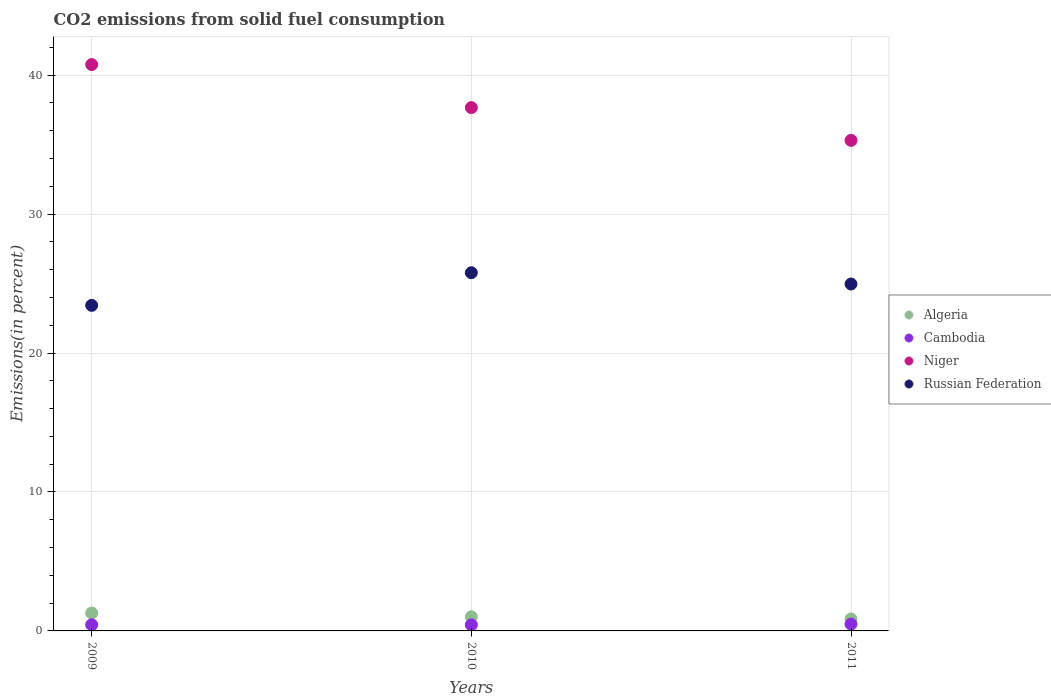Is the number of dotlines equal to the number of legend labels?
Offer a very short reply. Yes. What is the total CO2 emitted in Algeria in 2009?
Make the answer very short. 1.29. Across all years, what is the maximum total CO2 emitted in Algeria?
Make the answer very short. 1.29. Across all years, what is the minimum total CO2 emitted in Cambodia?
Your answer should be very brief. 0.44. In which year was the total CO2 emitted in Cambodia maximum?
Make the answer very short. 2011. What is the total total CO2 emitted in Niger in the graph?
Provide a succinct answer. 113.74. What is the difference between the total CO2 emitted in Cambodia in 2009 and that in 2010?
Your answer should be compact. 0.01. What is the difference between the total CO2 emitted in Algeria in 2010 and the total CO2 emitted in Cambodia in 2009?
Ensure brevity in your answer.  0.58. What is the average total CO2 emitted in Russian Federation per year?
Your answer should be compact. 24.73. In the year 2009, what is the difference between the total CO2 emitted in Niger and total CO2 emitted in Cambodia?
Offer a terse response. 40.32. What is the ratio of the total CO2 emitted in Algeria in 2009 to that in 2010?
Make the answer very short. 1.26. What is the difference between the highest and the second highest total CO2 emitted in Cambodia?
Ensure brevity in your answer.  0.05. What is the difference between the highest and the lowest total CO2 emitted in Cambodia?
Ensure brevity in your answer.  0.05. Is the sum of the total CO2 emitted in Cambodia in 2010 and 2011 greater than the maximum total CO2 emitted in Niger across all years?
Your answer should be very brief. No. Is it the case that in every year, the sum of the total CO2 emitted in Russian Federation and total CO2 emitted in Algeria  is greater than the sum of total CO2 emitted in Niger and total CO2 emitted in Cambodia?
Your answer should be very brief. Yes. Is it the case that in every year, the sum of the total CO2 emitted in Cambodia and total CO2 emitted in Russian Federation  is greater than the total CO2 emitted in Algeria?
Give a very brief answer. Yes. Does the total CO2 emitted in Algeria monotonically increase over the years?
Provide a succinct answer. No. How many dotlines are there?
Ensure brevity in your answer.  4. How many years are there in the graph?
Provide a succinct answer. 3. Are the values on the major ticks of Y-axis written in scientific E-notation?
Provide a short and direct response. No. Does the graph contain any zero values?
Your answer should be compact. No. How are the legend labels stacked?
Your answer should be compact. Vertical. What is the title of the graph?
Your response must be concise. CO2 emissions from solid fuel consumption. Does "Czech Republic" appear as one of the legend labels in the graph?
Your answer should be very brief. No. What is the label or title of the X-axis?
Your response must be concise. Years. What is the label or title of the Y-axis?
Your answer should be compact. Emissions(in percent). What is the Emissions(in percent) of Algeria in 2009?
Ensure brevity in your answer.  1.29. What is the Emissions(in percent) in Cambodia in 2009?
Your answer should be compact. 0.44. What is the Emissions(in percent) of Niger in 2009?
Make the answer very short. 40.76. What is the Emissions(in percent) of Russian Federation in 2009?
Offer a terse response. 23.43. What is the Emissions(in percent) of Algeria in 2010?
Give a very brief answer. 1.02. What is the Emissions(in percent) of Cambodia in 2010?
Give a very brief answer. 0.44. What is the Emissions(in percent) in Niger in 2010?
Offer a very short reply. 37.67. What is the Emissions(in percent) in Russian Federation in 2010?
Make the answer very short. 25.78. What is the Emissions(in percent) in Algeria in 2011?
Provide a succinct answer. 0.86. What is the Emissions(in percent) of Cambodia in 2011?
Ensure brevity in your answer.  0.49. What is the Emissions(in percent) in Niger in 2011?
Offer a terse response. 35.31. What is the Emissions(in percent) in Russian Federation in 2011?
Offer a terse response. 24.97. Across all years, what is the maximum Emissions(in percent) of Algeria?
Your answer should be compact. 1.29. Across all years, what is the maximum Emissions(in percent) of Cambodia?
Offer a terse response. 0.49. Across all years, what is the maximum Emissions(in percent) in Niger?
Offer a very short reply. 40.76. Across all years, what is the maximum Emissions(in percent) of Russian Federation?
Make the answer very short. 25.78. Across all years, what is the minimum Emissions(in percent) in Algeria?
Offer a terse response. 0.86. Across all years, what is the minimum Emissions(in percent) of Cambodia?
Provide a short and direct response. 0.44. Across all years, what is the minimum Emissions(in percent) of Niger?
Offer a terse response. 35.31. Across all years, what is the minimum Emissions(in percent) of Russian Federation?
Ensure brevity in your answer.  23.43. What is the total Emissions(in percent) of Algeria in the graph?
Provide a succinct answer. 3.17. What is the total Emissions(in percent) of Cambodia in the graph?
Your answer should be compact. 1.37. What is the total Emissions(in percent) of Niger in the graph?
Your answer should be compact. 113.74. What is the total Emissions(in percent) in Russian Federation in the graph?
Provide a succinct answer. 74.19. What is the difference between the Emissions(in percent) in Algeria in 2009 and that in 2010?
Ensure brevity in your answer.  0.27. What is the difference between the Emissions(in percent) of Cambodia in 2009 and that in 2010?
Ensure brevity in your answer.  0.01. What is the difference between the Emissions(in percent) in Niger in 2009 and that in 2010?
Offer a terse response. 3.1. What is the difference between the Emissions(in percent) of Russian Federation in 2009 and that in 2010?
Your response must be concise. -2.35. What is the difference between the Emissions(in percent) of Algeria in 2009 and that in 2011?
Ensure brevity in your answer.  0.43. What is the difference between the Emissions(in percent) in Cambodia in 2009 and that in 2011?
Offer a very short reply. -0.05. What is the difference between the Emissions(in percent) of Niger in 2009 and that in 2011?
Provide a succinct answer. 5.46. What is the difference between the Emissions(in percent) in Russian Federation in 2009 and that in 2011?
Your answer should be very brief. -1.54. What is the difference between the Emissions(in percent) of Algeria in 2010 and that in 2011?
Make the answer very short. 0.16. What is the difference between the Emissions(in percent) in Cambodia in 2010 and that in 2011?
Give a very brief answer. -0.05. What is the difference between the Emissions(in percent) of Niger in 2010 and that in 2011?
Ensure brevity in your answer.  2.36. What is the difference between the Emissions(in percent) in Russian Federation in 2010 and that in 2011?
Make the answer very short. 0.81. What is the difference between the Emissions(in percent) of Algeria in 2009 and the Emissions(in percent) of Cambodia in 2010?
Make the answer very short. 0.85. What is the difference between the Emissions(in percent) of Algeria in 2009 and the Emissions(in percent) of Niger in 2010?
Offer a terse response. -36.38. What is the difference between the Emissions(in percent) in Algeria in 2009 and the Emissions(in percent) in Russian Federation in 2010?
Ensure brevity in your answer.  -24.49. What is the difference between the Emissions(in percent) of Cambodia in 2009 and the Emissions(in percent) of Niger in 2010?
Offer a terse response. -37.23. What is the difference between the Emissions(in percent) of Cambodia in 2009 and the Emissions(in percent) of Russian Federation in 2010?
Ensure brevity in your answer.  -25.34. What is the difference between the Emissions(in percent) of Niger in 2009 and the Emissions(in percent) of Russian Federation in 2010?
Your answer should be compact. 14.98. What is the difference between the Emissions(in percent) of Algeria in 2009 and the Emissions(in percent) of Cambodia in 2011?
Offer a terse response. 0.8. What is the difference between the Emissions(in percent) of Algeria in 2009 and the Emissions(in percent) of Niger in 2011?
Your answer should be very brief. -34.02. What is the difference between the Emissions(in percent) in Algeria in 2009 and the Emissions(in percent) in Russian Federation in 2011?
Make the answer very short. -23.68. What is the difference between the Emissions(in percent) in Cambodia in 2009 and the Emissions(in percent) in Niger in 2011?
Your answer should be compact. -34.87. What is the difference between the Emissions(in percent) of Cambodia in 2009 and the Emissions(in percent) of Russian Federation in 2011?
Your answer should be very brief. -24.53. What is the difference between the Emissions(in percent) of Niger in 2009 and the Emissions(in percent) of Russian Federation in 2011?
Your answer should be very brief. 15.79. What is the difference between the Emissions(in percent) of Algeria in 2010 and the Emissions(in percent) of Cambodia in 2011?
Your answer should be compact. 0.53. What is the difference between the Emissions(in percent) of Algeria in 2010 and the Emissions(in percent) of Niger in 2011?
Your answer should be very brief. -34.29. What is the difference between the Emissions(in percent) of Algeria in 2010 and the Emissions(in percent) of Russian Federation in 2011?
Your answer should be compact. -23.95. What is the difference between the Emissions(in percent) in Cambodia in 2010 and the Emissions(in percent) in Niger in 2011?
Provide a succinct answer. -34.87. What is the difference between the Emissions(in percent) in Cambodia in 2010 and the Emissions(in percent) in Russian Federation in 2011?
Your answer should be compact. -24.53. What is the difference between the Emissions(in percent) in Niger in 2010 and the Emissions(in percent) in Russian Federation in 2011?
Offer a very short reply. 12.7. What is the average Emissions(in percent) in Algeria per year?
Your answer should be compact. 1.06. What is the average Emissions(in percent) of Cambodia per year?
Your answer should be very brief. 0.46. What is the average Emissions(in percent) in Niger per year?
Your response must be concise. 37.91. What is the average Emissions(in percent) in Russian Federation per year?
Provide a short and direct response. 24.73. In the year 2009, what is the difference between the Emissions(in percent) of Algeria and Emissions(in percent) of Cambodia?
Your answer should be compact. 0.85. In the year 2009, what is the difference between the Emissions(in percent) in Algeria and Emissions(in percent) in Niger?
Offer a very short reply. -39.47. In the year 2009, what is the difference between the Emissions(in percent) of Algeria and Emissions(in percent) of Russian Federation?
Give a very brief answer. -22.14. In the year 2009, what is the difference between the Emissions(in percent) of Cambodia and Emissions(in percent) of Niger?
Provide a short and direct response. -40.32. In the year 2009, what is the difference between the Emissions(in percent) of Cambodia and Emissions(in percent) of Russian Federation?
Offer a terse response. -22.99. In the year 2009, what is the difference between the Emissions(in percent) in Niger and Emissions(in percent) in Russian Federation?
Your answer should be very brief. 17.33. In the year 2010, what is the difference between the Emissions(in percent) of Algeria and Emissions(in percent) of Cambodia?
Provide a succinct answer. 0.58. In the year 2010, what is the difference between the Emissions(in percent) in Algeria and Emissions(in percent) in Niger?
Your response must be concise. -36.65. In the year 2010, what is the difference between the Emissions(in percent) of Algeria and Emissions(in percent) of Russian Federation?
Your answer should be compact. -24.76. In the year 2010, what is the difference between the Emissions(in percent) in Cambodia and Emissions(in percent) in Niger?
Your response must be concise. -37.23. In the year 2010, what is the difference between the Emissions(in percent) in Cambodia and Emissions(in percent) in Russian Federation?
Your answer should be very brief. -25.35. In the year 2010, what is the difference between the Emissions(in percent) in Niger and Emissions(in percent) in Russian Federation?
Your response must be concise. 11.89. In the year 2011, what is the difference between the Emissions(in percent) of Algeria and Emissions(in percent) of Cambodia?
Offer a very short reply. 0.37. In the year 2011, what is the difference between the Emissions(in percent) in Algeria and Emissions(in percent) in Niger?
Give a very brief answer. -34.45. In the year 2011, what is the difference between the Emissions(in percent) of Algeria and Emissions(in percent) of Russian Federation?
Make the answer very short. -24.11. In the year 2011, what is the difference between the Emissions(in percent) in Cambodia and Emissions(in percent) in Niger?
Provide a short and direct response. -34.82. In the year 2011, what is the difference between the Emissions(in percent) in Cambodia and Emissions(in percent) in Russian Federation?
Your response must be concise. -24.48. In the year 2011, what is the difference between the Emissions(in percent) in Niger and Emissions(in percent) in Russian Federation?
Keep it short and to the point. 10.34. What is the ratio of the Emissions(in percent) of Algeria in 2009 to that in 2010?
Provide a succinct answer. 1.26. What is the ratio of the Emissions(in percent) in Cambodia in 2009 to that in 2010?
Offer a terse response. 1.01. What is the ratio of the Emissions(in percent) of Niger in 2009 to that in 2010?
Provide a succinct answer. 1.08. What is the ratio of the Emissions(in percent) in Russian Federation in 2009 to that in 2010?
Your answer should be compact. 0.91. What is the ratio of the Emissions(in percent) of Algeria in 2009 to that in 2011?
Provide a succinct answer. 1.5. What is the ratio of the Emissions(in percent) of Cambodia in 2009 to that in 2011?
Keep it short and to the point. 0.91. What is the ratio of the Emissions(in percent) in Niger in 2009 to that in 2011?
Your answer should be compact. 1.15. What is the ratio of the Emissions(in percent) of Russian Federation in 2009 to that in 2011?
Offer a terse response. 0.94. What is the ratio of the Emissions(in percent) of Algeria in 2010 to that in 2011?
Ensure brevity in your answer.  1.19. What is the ratio of the Emissions(in percent) in Cambodia in 2010 to that in 2011?
Keep it short and to the point. 0.89. What is the ratio of the Emissions(in percent) in Niger in 2010 to that in 2011?
Provide a short and direct response. 1.07. What is the ratio of the Emissions(in percent) of Russian Federation in 2010 to that in 2011?
Your answer should be compact. 1.03. What is the difference between the highest and the second highest Emissions(in percent) in Algeria?
Your answer should be compact. 0.27. What is the difference between the highest and the second highest Emissions(in percent) in Cambodia?
Give a very brief answer. 0.05. What is the difference between the highest and the second highest Emissions(in percent) in Niger?
Your response must be concise. 3.1. What is the difference between the highest and the second highest Emissions(in percent) of Russian Federation?
Your answer should be compact. 0.81. What is the difference between the highest and the lowest Emissions(in percent) in Algeria?
Offer a terse response. 0.43. What is the difference between the highest and the lowest Emissions(in percent) of Cambodia?
Provide a short and direct response. 0.05. What is the difference between the highest and the lowest Emissions(in percent) in Niger?
Keep it short and to the point. 5.46. What is the difference between the highest and the lowest Emissions(in percent) of Russian Federation?
Provide a short and direct response. 2.35. 